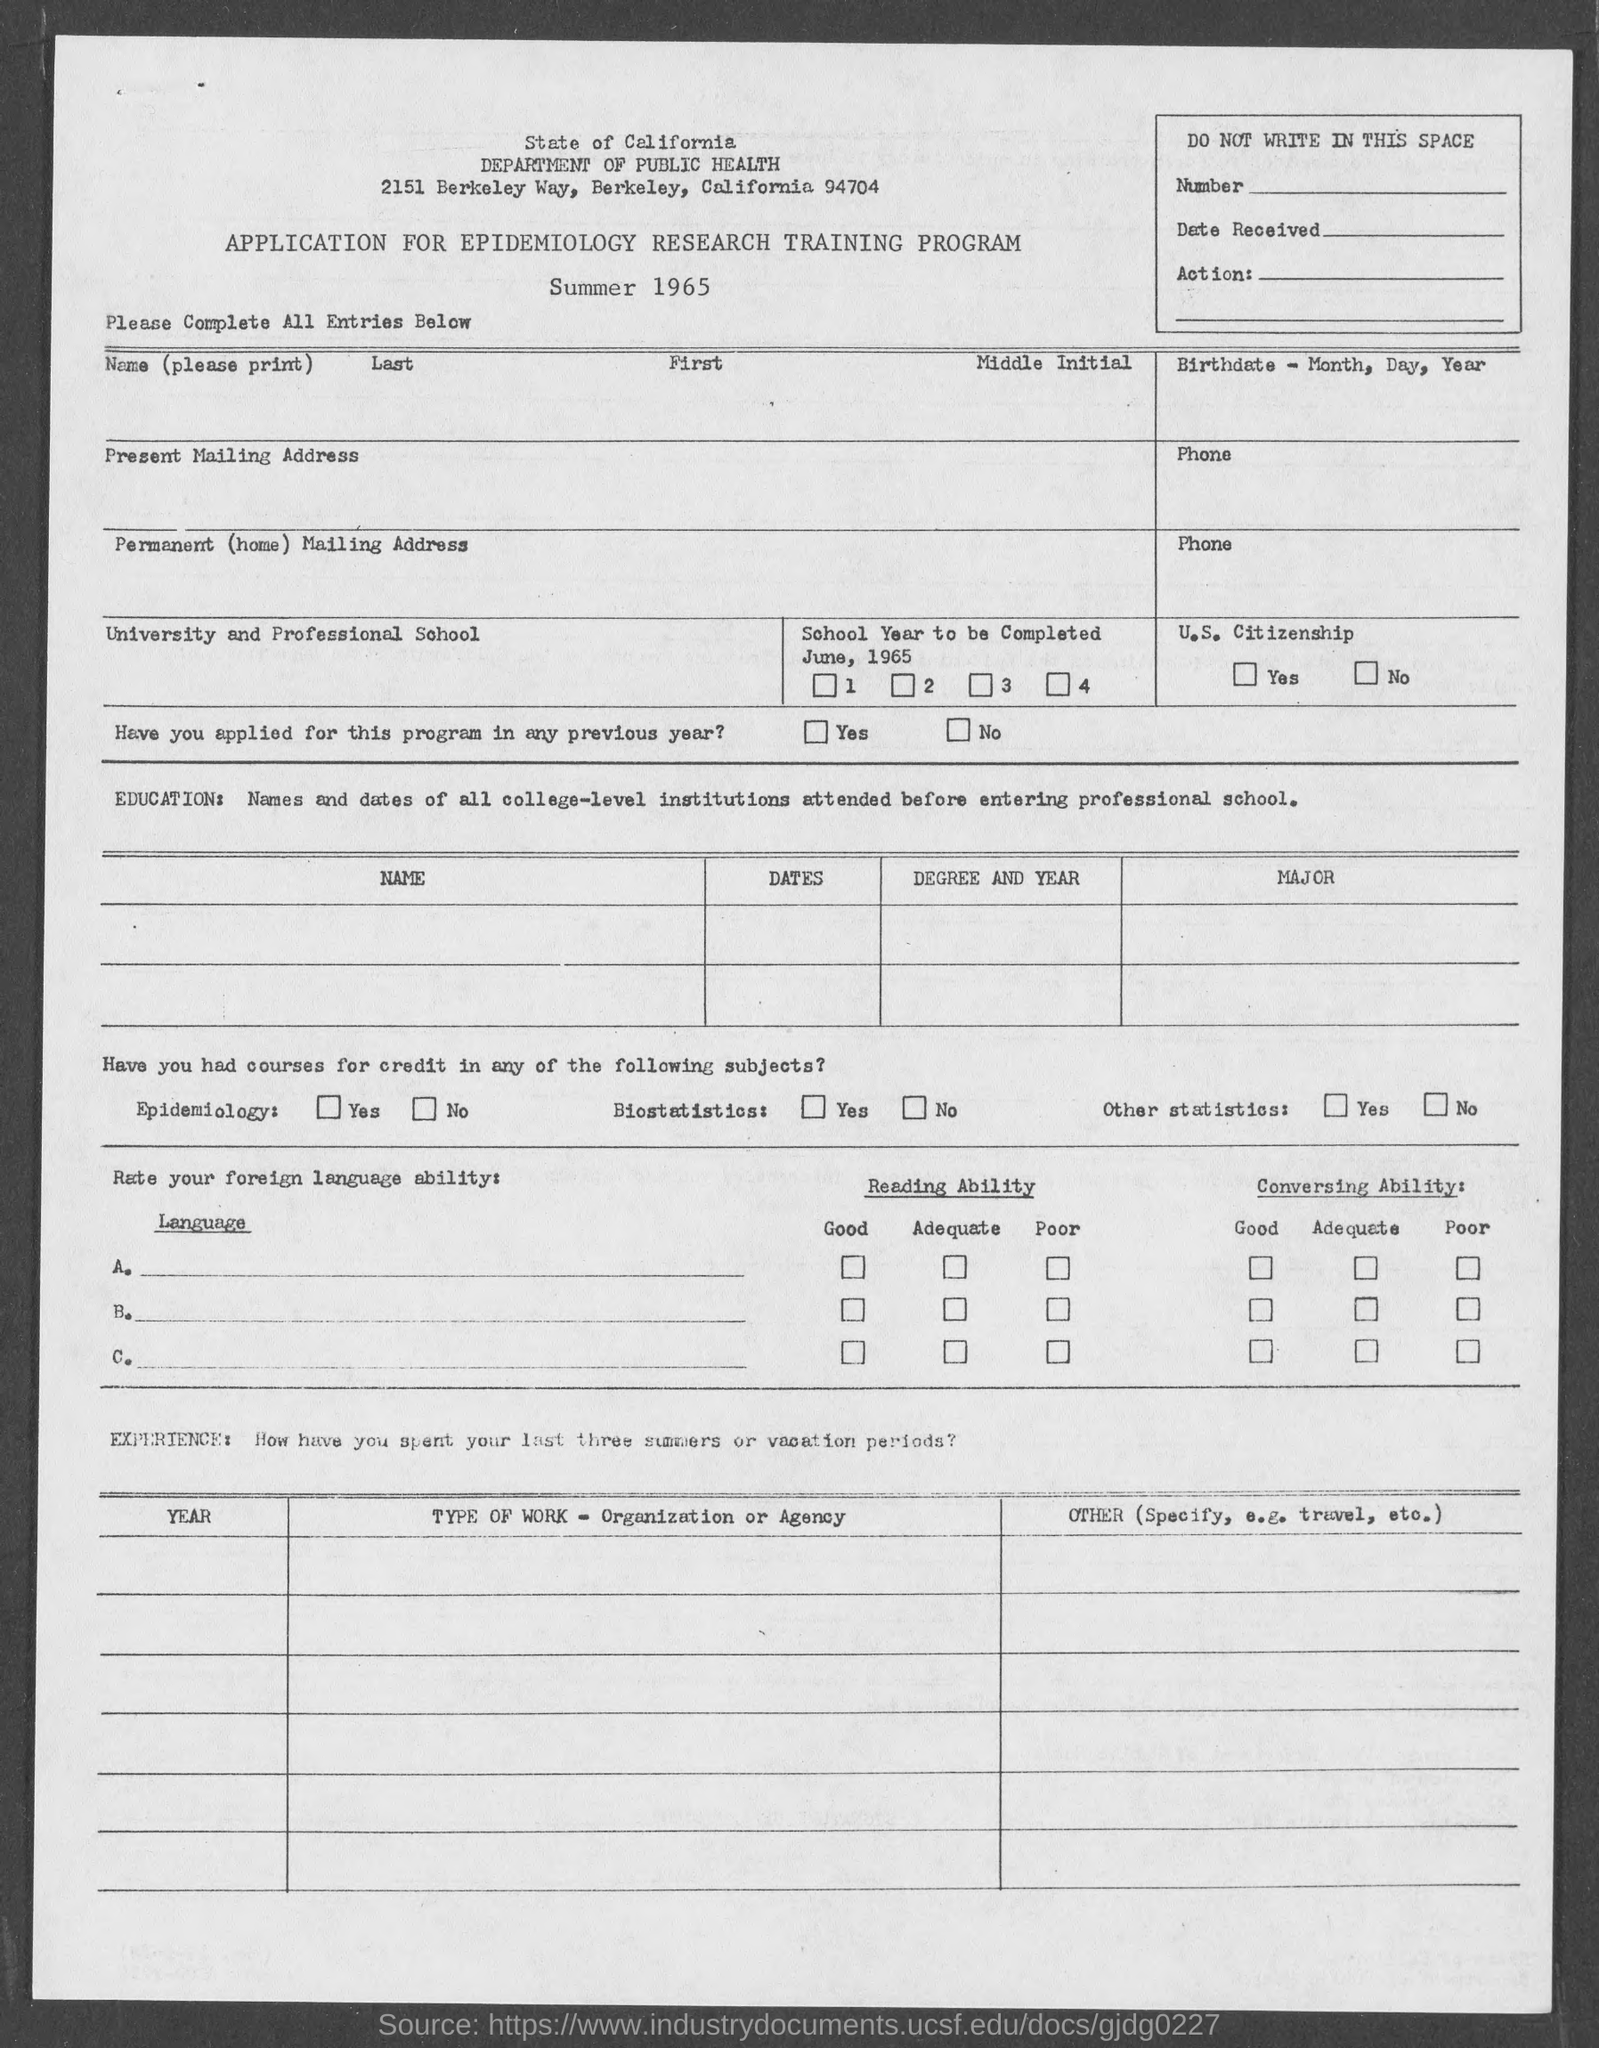Identify some key points in this picture. The Department of Public Health is located in Berkeley, a city in which it is situated. 